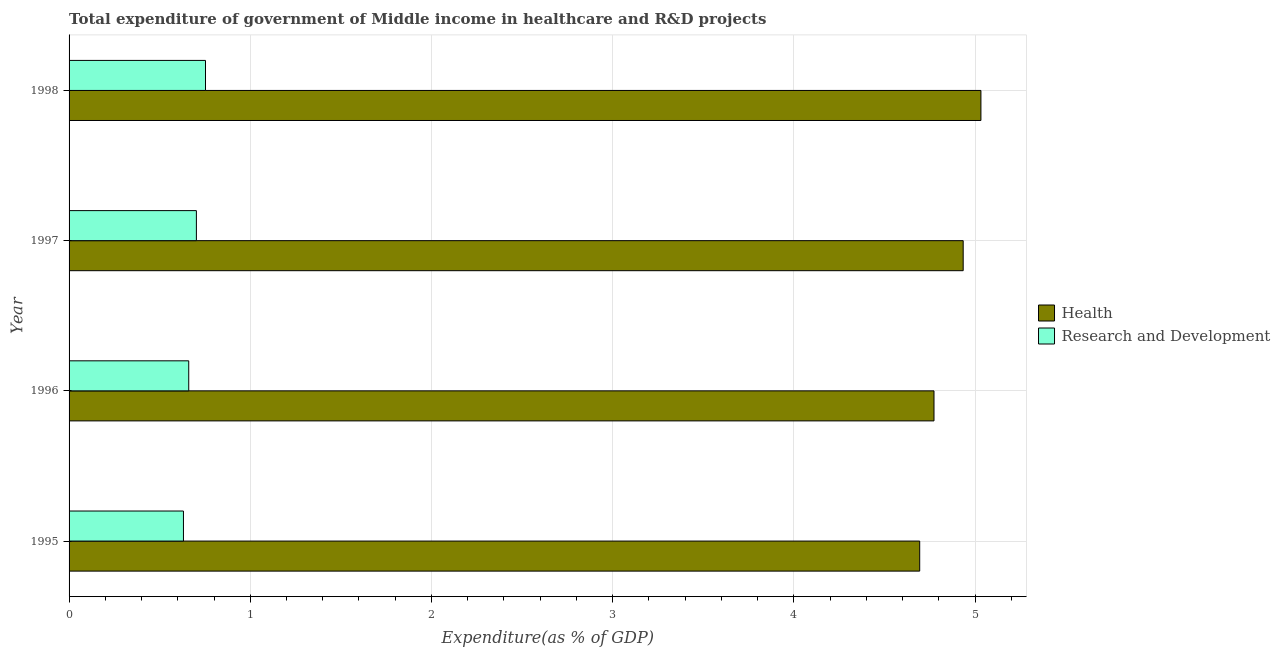Are the number of bars per tick equal to the number of legend labels?
Your answer should be compact. Yes. Are the number of bars on each tick of the Y-axis equal?
Your answer should be compact. Yes. What is the label of the 3rd group of bars from the top?
Provide a succinct answer. 1996. In how many cases, is the number of bars for a given year not equal to the number of legend labels?
Keep it short and to the point. 0. What is the expenditure in r&d in 1998?
Your response must be concise. 0.75. Across all years, what is the maximum expenditure in r&d?
Your answer should be very brief. 0.75. Across all years, what is the minimum expenditure in healthcare?
Give a very brief answer. 4.69. In which year was the expenditure in healthcare maximum?
Offer a very short reply. 1998. In which year was the expenditure in healthcare minimum?
Provide a succinct answer. 1995. What is the total expenditure in r&d in the graph?
Provide a succinct answer. 2.75. What is the difference between the expenditure in r&d in 1996 and that in 1997?
Your answer should be compact. -0.04. What is the difference between the expenditure in healthcare in 1998 and the expenditure in r&d in 1995?
Keep it short and to the point. 4.4. What is the average expenditure in r&d per year?
Your answer should be compact. 0.69. In the year 1996, what is the difference between the expenditure in r&d and expenditure in healthcare?
Provide a succinct answer. -4.11. In how many years, is the expenditure in healthcare greater than 1.4 %?
Your response must be concise. 4. What is the ratio of the expenditure in healthcare in 1997 to that in 1998?
Keep it short and to the point. 0.98. Is the difference between the expenditure in healthcare in 1995 and 1997 greater than the difference between the expenditure in r&d in 1995 and 1997?
Your answer should be compact. No. What is the difference between the highest and the second highest expenditure in healthcare?
Ensure brevity in your answer.  0.1. What is the difference between the highest and the lowest expenditure in r&d?
Keep it short and to the point. 0.12. What does the 1st bar from the top in 1998 represents?
Ensure brevity in your answer.  Research and Development. What does the 2nd bar from the bottom in 1998 represents?
Your answer should be very brief. Research and Development. How many bars are there?
Offer a terse response. 8. Are all the bars in the graph horizontal?
Make the answer very short. Yes. How many years are there in the graph?
Keep it short and to the point. 4. Are the values on the major ticks of X-axis written in scientific E-notation?
Give a very brief answer. No. Does the graph contain grids?
Your answer should be compact. Yes. Where does the legend appear in the graph?
Provide a short and direct response. Center right. How are the legend labels stacked?
Your answer should be compact. Vertical. What is the title of the graph?
Keep it short and to the point. Total expenditure of government of Middle income in healthcare and R&D projects. What is the label or title of the X-axis?
Offer a terse response. Expenditure(as % of GDP). What is the label or title of the Y-axis?
Keep it short and to the point. Year. What is the Expenditure(as % of GDP) in Health in 1995?
Your response must be concise. 4.69. What is the Expenditure(as % of GDP) of Research and Development in 1995?
Keep it short and to the point. 0.63. What is the Expenditure(as % of GDP) in Health in 1996?
Offer a terse response. 4.77. What is the Expenditure(as % of GDP) in Research and Development in 1996?
Your response must be concise. 0.66. What is the Expenditure(as % of GDP) in Health in 1997?
Make the answer very short. 4.93. What is the Expenditure(as % of GDP) in Research and Development in 1997?
Offer a very short reply. 0.7. What is the Expenditure(as % of GDP) of Health in 1998?
Ensure brevity in your answer.  5.03. What is the Expenditure(as % of GDP) of Research and Development in 1998?
Provide a succinct answer. 0.75. Across all years, what is the maximum Expenditure(as % of GDP) in Health?
Keep it short and to the point. 5.03. Across all years, what is the maximum Expenditure(as % of GDP) in Research and Development?
Ensure brevity in your answer.  0.75. Across all years, what is the minimum Expenditure(as % of GDP) of Health?
Offer a terse response. 4.69. Across all years, what is the minimum Expenditure(as % of GDP) in Research and Development?
Offer a terse response. 0.63. What is the total Expenditure(as % of GDP) of Health in the graph?
Make the answer very short. 19.43. What is the total Expenditure(as % of GDP) in Research and Development in the graph?
Give a very brief answer. 2.75. What is the difference between the Expenditure(as % of GDP) in Health in 1995 and that in 1996?
Offer a very short reply. -0.08. What is the difference between the Expenditure(as % of GDP) in Research and Development in 1995 and that in 1996?
Offer a terse response. -0.03. What is the difference between the Expenditure(as % of GDP) in Health in 1995 and that in 1997?
Your answer should be compact. -0.24. What is the difference between the Expenditure(as % of GDP) in Research and Development in 1995 and that in 1997?
Provide a short and direct response. -0.07. What is the difference between the Expenditure(as % of GDP) of Health in 1995 and that in 1998?
Your answer should be compact. -0.34. What is the difference between the Expenditure(as % of GDP) of Research and Development in 1995 and that in 1998?
Ensure brevity in your answer.  -0.12. What is the difference between the Expenditure(as % of GDP) of Health in 1996 and that in 1997?
Offer a terse response. -0.16. What is the difference between the Expenditure(as % of GDP) of Research and Development in 1996 and that in 1997?
Make the answer very short. -0.04. What is the difference between the Expenditure(as % of GDP) of Health in 1996 and that in 1998?
Your response must be concise. -0.26. What is the difference between the Expenditure(as % of GDP) of Research and Development in 1996 and that in 1998?
Keep it short and to the point. -0.09. What is the difference between the Expenditure(as % of GDP) in Health in 1997 and that in 1998?
Give a very brief answer. -0.1. What is the difference between the Expenditure(as % of GDP) in Research and Development in 1997 and that in 1998?
Ensure brevity in your answer.  -0.05. What is the difference between the Expenditure(as % of GDP) in Health in 1995 and the Expenditure(as % of GDP) in Research and Development in 1996?
Offer a very short reply. 4.03. What is the difference between the Expenditure(as % of GDP) in Health in 1995 and the Expenditure(as % of GDP) in Research and Development in 1997?
Keep it short and to the point. 3.99. What is the difference between the Expenditure(as % of GDP) in Health in 1995 and the Expenditure(as % of GDP) in Research and Development in 1998?
Keep it short and to the point. 3.94. What is the difference between the Expenditure(as % of GDP) in Health in 1996 and the Expenditure(as % of GDP) in Research and Development in 1997?
Ensure brevity in your answer.  4.07. What is the difference between the Expenditure(as % of GDP) of Health in 1996 and the Expenditure(as % of GDP) of Research and Development in 1998?
Keep it short and to the point. 4.02. What is the difference between the Expenditure(as % of GDP) in Health in 1997 and the Expenditure(as % of GDP) in Research and Development in 1998?
Offer a very short reply. 4.18. What is the average Expenditure(as % of GDP) in Health per year?
Your answer should be very brief. 4.86. What is the average Expenditure(as % of GDP) in Research and Development per year?
Offer a terse response. 0.69. In the year 1995, what is the difference between the Expenditure(as % of GDP) of Health and Expenditure(as % of GDP) of Research and Development?
Your answer should be very brief. 4.06. In the year 1996, what is the difference between the Expenditure(as % of GDP) in Health and Expenditure(as % of GDP) in Research and Development?
Your answer should be compact. 4.11. In the year 1997, what is the difference between the Expenditure(as % of GDP) of Health and Expenditure(as % of GDP) of Research and Development?
Your response must be concise. 4.23. In the year 1998, what is the difference between the Expenditure(as % of GDP) in Health and Expenditure(as % of GDP) in Research and Development?
Offer a terse response. 4.28. What is the ratio of the Expenditure(as % of GDP) of Health in 1995 to that in 1996?
Give a very brief answer. 0.98. What is the ratio of the Expenditure(as % of GDP) of Research and Development in 1995 to that in 1996?
Give a very brief answer. 0.96. What is the ratio of the Expenditure(as % of GDP) in Health in 1995 to that in 1997?
Offer a very short reply. 0.95. What is the ratio of the Expenditure(as % of GDP) in Research and Development in 1995 to that in 1997?
Give a very brief answer. 0.9. What is the ratio of the Expenditure(as % of GDP) of Health in 1995 to that in 1998?
Offer a terse response. 0.93. What is the ratio of the Expenditure(as % of GDP) in Research and Development in 1995 to that in 1998?
Offer a very short reply. 0.84. What is the ratio of the Expenditure(as % of GDP) of Health in 1996 to that in 1997?
Keep it short and to the point. 0.97. What is the ratio of the Expenditure(as % of GDP) in Research and Development in 1996 to that in 1997?
Your response must be concise. 0.94. What is the ratio of the Expenditure(as % of GDP) of Health in 1996 to that in 1998?
Make the answer very short. 0.95. What is the ratio of the Expenditure(as % of GDP) of Research and Development in 1996 to that in 1998?
Offer a terse response. 0.88. What is the ratio of the Expenditure(as % of GDP) of Health in 1997 to that in 1998?
Ensure brevity in your answer.  0.98. What is the ratio of the Expenditure(as % of GDP) of Research and Development in 1997 to that in 1998?
Provide a succinct answer. 0.93. What is the difference between the highest and the second highest Expenditure(as % of GDP) in Health?
Ensure brevity in your answer.  0.1. What is the difference between the highest and the second highest Expenditure(as % of GDP) of Research and Development?
Provide a short and direct response. 0.05. What is the difference between the highest and the lowest Expenditure(as % of GDP) in Health?
Provide a short and direct response. 0.34. What is the difference between the highest and the lowest Expenditure(as % of GDP) in Research and Development?
Offer a terse response. 0.12. 